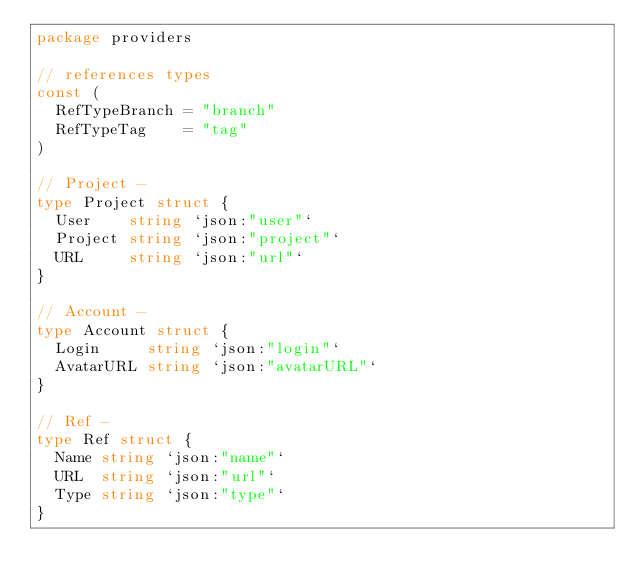Convert code to text. <code><loc_0><loc_0><loc_500><loc_500><_Go_>package providers

// references types
const (
	RefTypeBranch = "branch"
	RefTypeTag    = "tag"
)

// Project -
type Project struct {
	User    string `json:"user"`
	Project string `json:"project"`
	URL     string `json:"url"`
}

// Account -
type Account struct {
	Login     string `json:"login"`
	AvatarURL string `json:"avatarURL"`
}

// Ref -
type Ref struct {
	Name string `json:"name"`
	URL  string `json:"url"`
	Type string `json:"type"`
}
</code> 